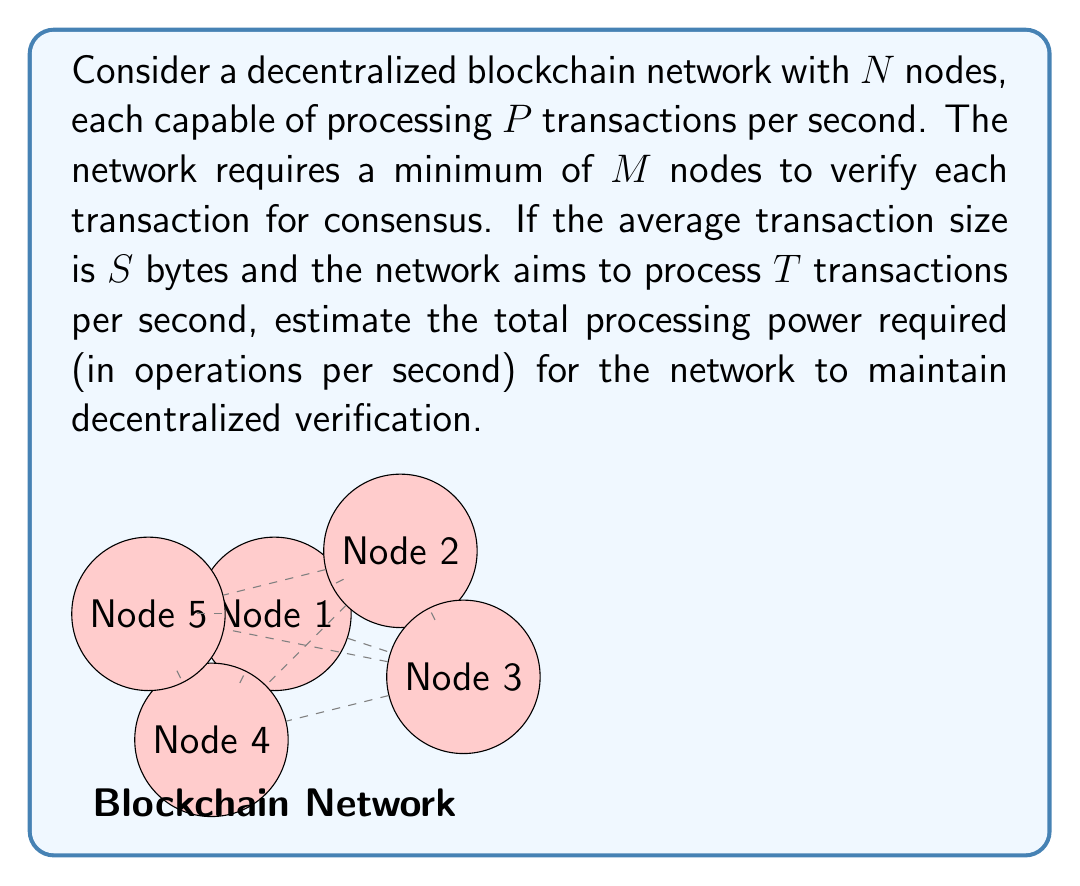Solve this math problem. Let's break this down step-by-step:

1) First, we need to calculate the number of verifications per second:
   $$V = T \times M$$
   Where $V$ is the total number of verifications per second.

2) Each verification requires processing the transaction data. The number of operations per verification can be estimated as proportional to the transaction size:
   $$O_{per\_verification} = k \times S$$
   Where $k$ is a constant factor representing the computational complexity per byte.

3) The total number of operations per second for the entire network is:
   $$O_{total} = V \times O_{per\_verification} = T \times M \times k \times S$$

4) To express this in terms of the processing power of individual nodes, we can divide by the number of transactions each node can process per second:
   $$P_{required} = \frac{O_{total}}{P} = \frac{T \times M \times k \times S}{P}$$

5) This gives us the equivalent number of fully utilized nodes. To ensure decentralization, we typically want more nodes than this minimum:
   $$N_{min} = \frac{P_{required}}{P} = \frac{T \times M \times k \times S}{P^2}$$

Therefore, the total processing power required for the network is:
$$P_{total} = N \times P \times \frac{T \times M \times k \times S}{P^2} = N \times T \times M \times k \times \frac{S}{P}$$

This formula gives us the total number of operations per second required for the entire network to maintain decentralized verification.
Answer: $N \times T \times M \times k \times \frac{S}{P}$ operations per second 